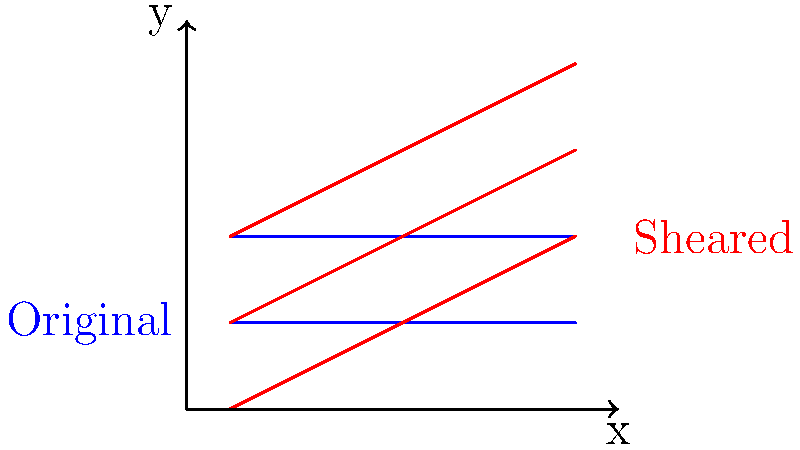In your bakery, you're designing a new layered pastry. The cross-section of the original pastry is represented by the blue lines, while the red lines show the pastry after applying a shear transformation. If the shear factor is $k$, and the transformation moves the top layer of the pastry 2 units to the right, what is the value of $k$? To solve this problem, let's follow these steps:

1) In a shear transformation, the general formula is:
   $x' = x + ky$
   $y' = y$
   Where $(x,y)$ is the original point and $(x',y')$ is the transformed point.

2) We can see that the top layer of the pastry (at $y=2$) has moved 2 units to the right.

3) Using the shear transformation formula:
   $x' = x + k(2)$
   $2 = 0 + k(2)$  (since the right edge moved from $x=0$ to $x=2$)

4) Simplifying:
   $2 = 2k$

5) Solving for $k$:
   $k = 2/2 = 1$

Therefore, the shear factor $k$ is 1.
Answer: $k = 1$ 